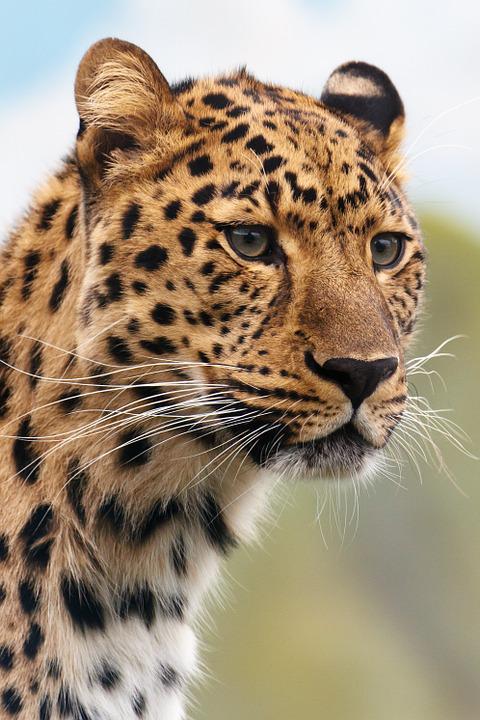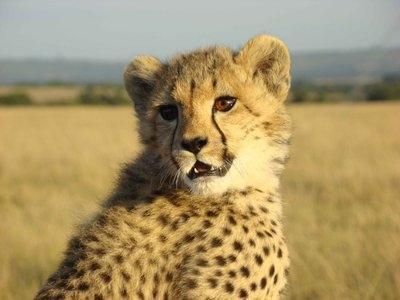The first image is the image on the left, the second image is the image on the right. For the images shown, is this caption "There is at least 1 leopard kitten." true? Answer yes or no. Yes. 